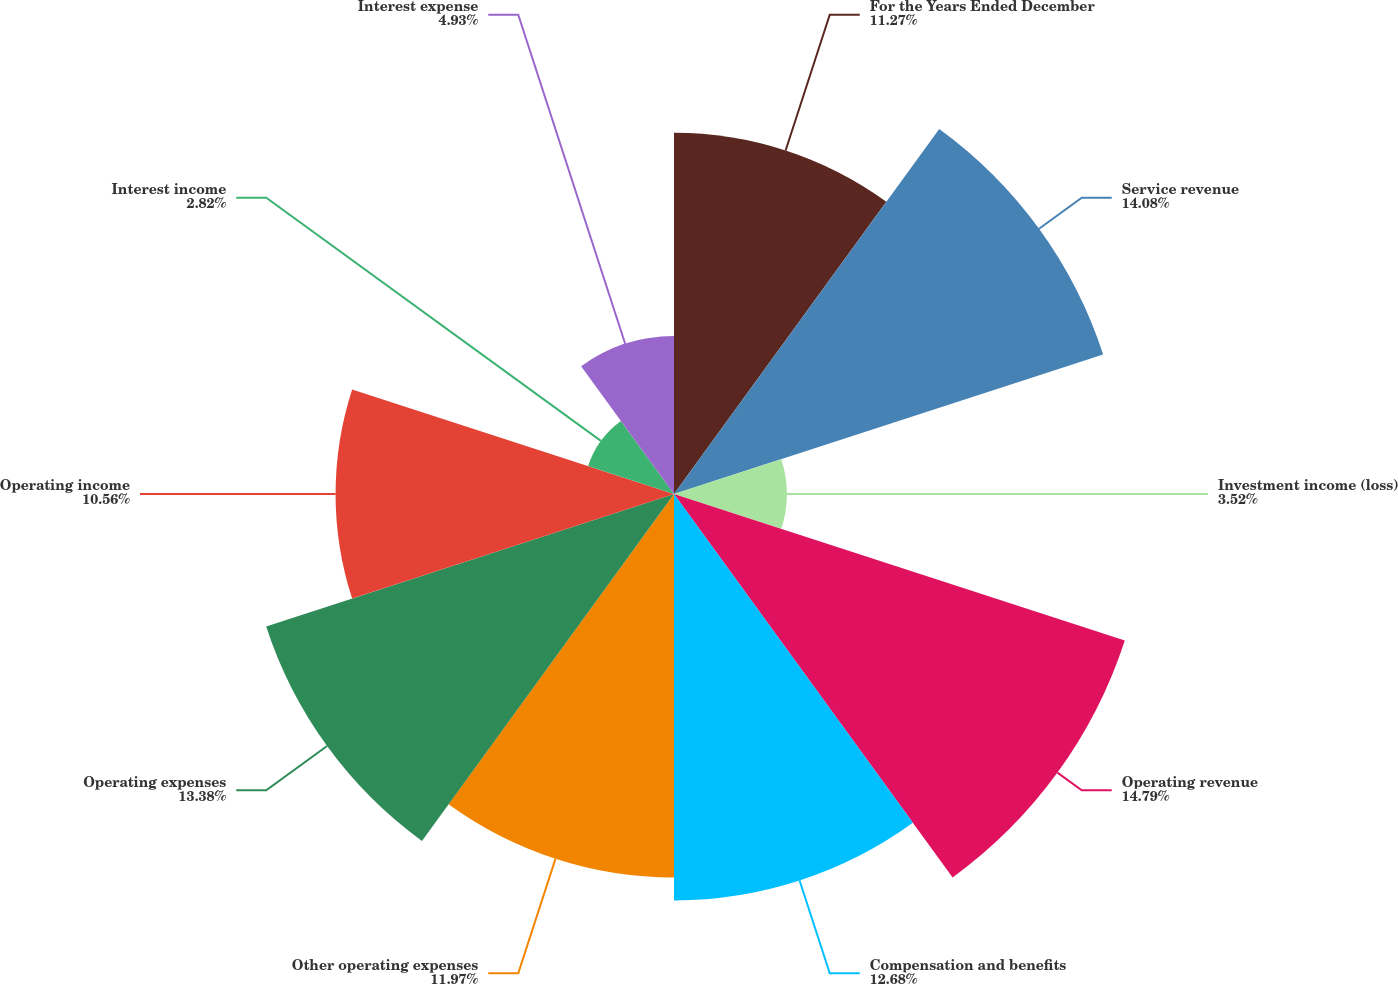Convert chart to OTSL. <chart><loc_0><loc_0><loc_500><loc_500><pie_chart><fcel>For the Years Ended December<fcel>Service revenue<fcel>Investment income (loss)<fcel>Operating revenue<fcel>Compensation and benefits<fcel>Other operating expenses<fcel>Operating expenses<fcel>Operating income<fcel>Interest income<fcel>Interest expense<nl><fcel>11.27%<fcel>14.08%<fcel>3.52%<fcel>14.79%<fcel>12.68%<fcel>11.97%<fcel>13.38%<fcel>10.56%<fcel>2.82%<fcel>4.93%<nl></chart> 